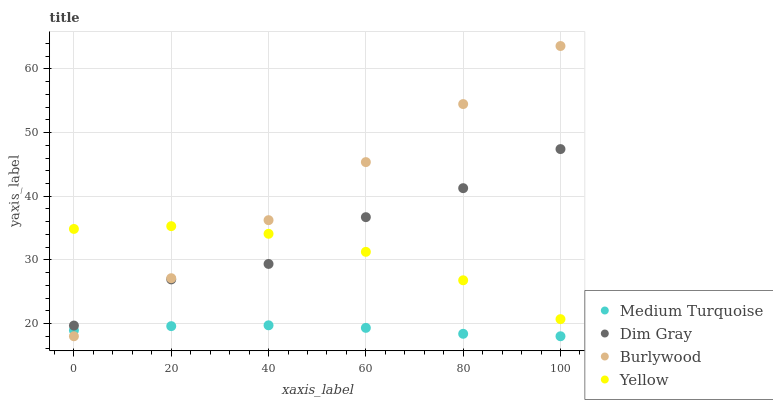Does Medium Turquoise have the minimum area under the curve?
Answer yes or no. Yes. Does Burlywood have the maximum area under the curve?
Answer yes or no. Yes. Does Dim Gray have the minimum area under the curve?
Answer yes or no. No. Does Dim Gray have the maximum area under the curve?
Answer yes or no. No. Is Burlywood the smoothest?
Answer yes or no. Yes. Is Dim Gray the roughest?
Answer yes or no. Yes. Is Yellow the smoothest?
Answer yes or no. No. Is Yellow the roughest?
Answer yes or no. No. Does Burlywood have the lowest value?
Answer yes or no. Yes. Does Dim Gray have the lowest value?
Answer yes or no. No. Does Burlywood have the highest value?
Answer yes or no. Yes. Does Dim Gray have the highest value?
Answer yes or no. No. Is Medium Turquoise less than Yellow?
Answer yes or no. Yes. Is Yellow greater than Medium Turquoise?
Answer yes or no. Yes. Does Medium Turquoise intersect Burlywood?
Answer yes or no. Yes. Is Medium Turquoise less than Burlywood?
Answer yes or no. No. Is Medium Turquoise greater than Burlywood?
Answer yes or no. No. Does Medium Turquoise intersect Yellow?
Answer yes or no. No. 